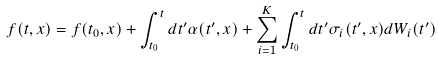Convert formula to latex. <formula><loc_0><loc_0><loc_500><loc_500>f ( t , x ) = f ( t _ { 0 } , x ) + \int _ { t _ { 0 } } ^ { t } d t ^ { \prime } \alpha ( t ^ { \prime } , x ) + \sum _ { i = 1 } ^ { K } \int _ { t _ { 0 } } ^ { t } d t ^ { \prime } \sigma _ { i } ( t ^ { \prime } , x ) d W _ { i } ( t ^ { \prime } )</formula> 